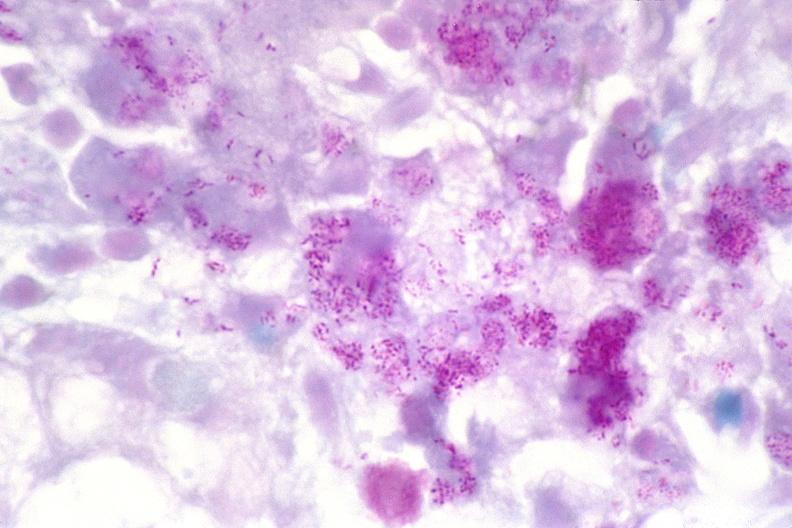what does this image show?
Answer the question using a single word or phrase. Lymph node 